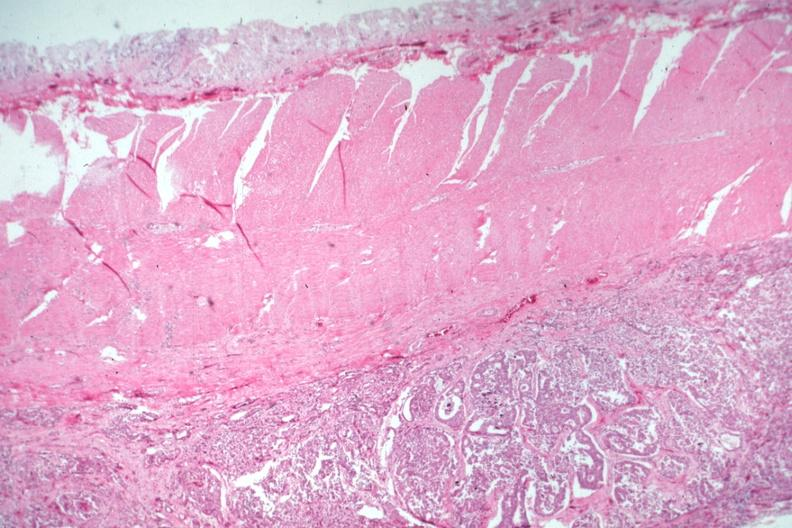does this image show carcinoma on peritoneal side of muscularis?
Answer the question using a single word or phrase. Yes 